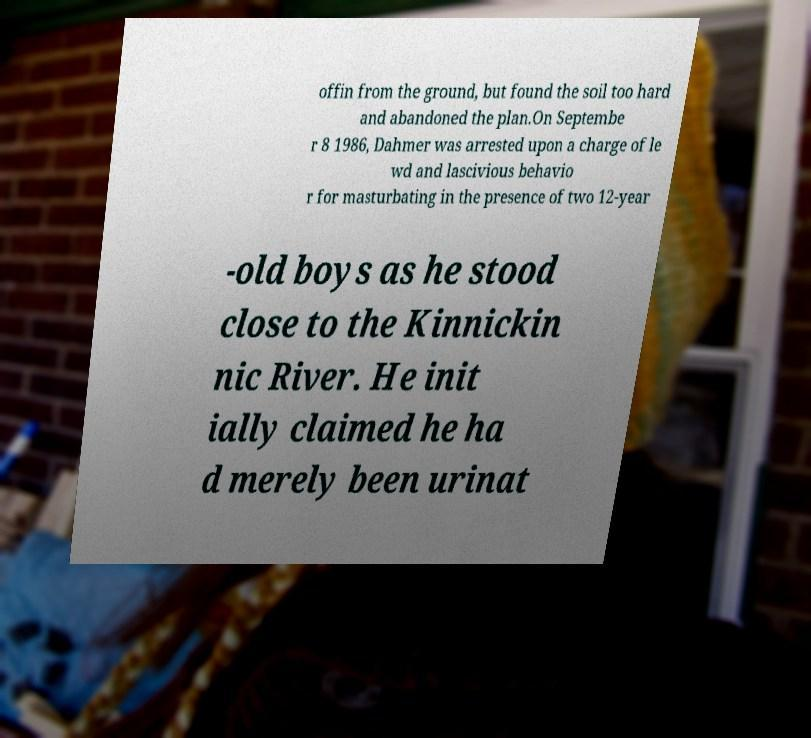For documentation purposes, I need the text within this image transcribed. Could you provide that? offin from the ground, but found the soil too hard and abandoned the plan.On Septembe r 8 1986, Dahmer was arrested upon a charge of le wd and lascivious behavio r for masturbating in the presence of two 12-year -old boys as he stood close to the Kinnickin nic River. He init ially claimed he ha d merely been urinat 